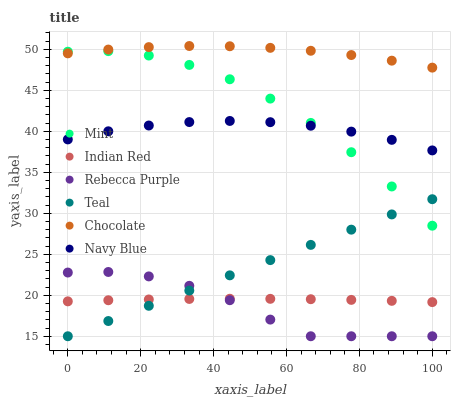Does Rebecca Purple have the minimum area under the curve?
Answer yes or no. Yes. Does Chocolate have the maximum area under the curve?
Answer yes or no. Yes. Does Navy Blue have the minimum area under the curve?
Answer yes or no. No. Does Navy Blue have the maximum area under the curve?
Answer yes or no. No. Is Teal the smoothest?
Answer yes or no. Yes. Is Mint the roughest?
Answer yes or no. Yes. Is Navy Blue the smoothest?
Answer yes or no. No. Is Navy Blue the roughest?
Answer yes or no. No. Does Rebecca Purple have the lowest value?
Answer yes or no. Yes. Does Navy Blue have the lowest value?
Answer yes or no. No. Does Chocolate have the highest value?
Answer yes or no. Yes. Does Navy Blue have the highest value?
Answer yes or no. No. Is Rebecca Purple less than Navy Blue?
Answer yes or no. Yes. Is Mint greater than Rebecca Purple?
Answer yes or no. Yes. Does Indian Red intersect Rebecca Purple?
Answer yes or no. Yes. Is Indian Red less than Rebecca Purple?
Answer yes or no. No. Is Indian Red greater than Rebecca Purple?
Answer yes or no. No. Does Rebecca Purple intersect Navy Blue?
Answer yes or no. No. 